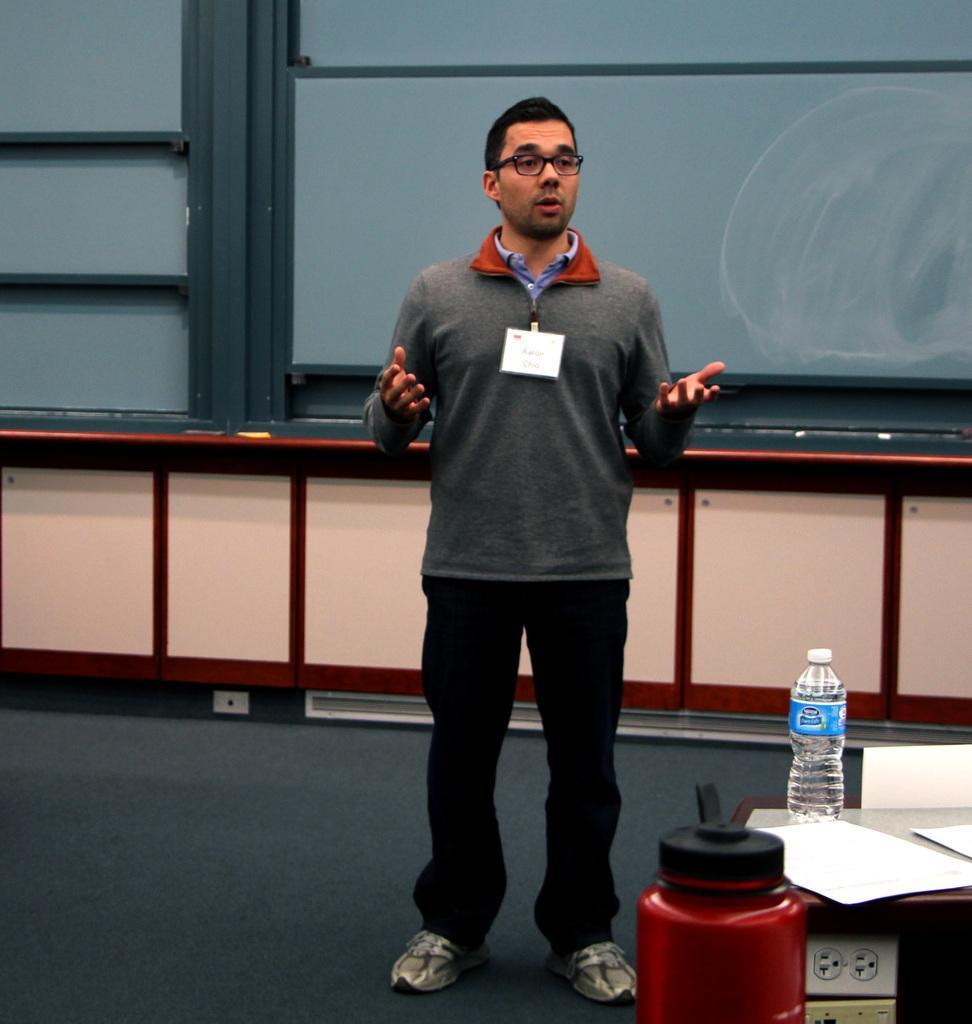How would you summarize this image in a sentence or two? This picture shows a man standing and speaking and we see water bottle and some papers on the table 